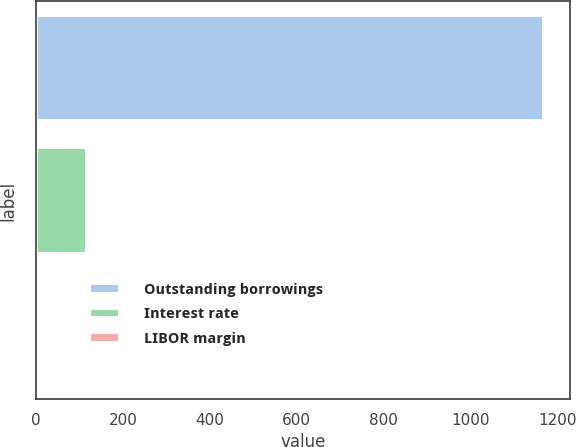<chart> <loc_0><loc_0><loc_500><loc_500><bar_chart><fcel>Outstanding borrowings<fcel>Interest rate<fcel>LIBOR margin<nl><fcel>1169.1<fcel>118.26<fcel>1.5<nl></chart> 